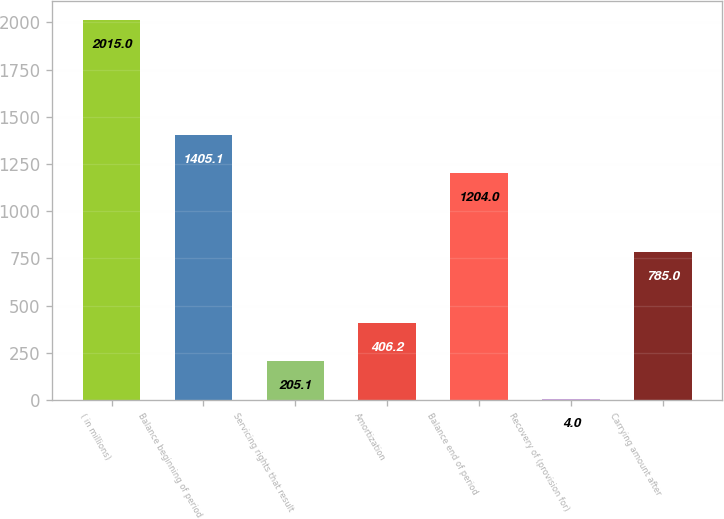Convert chart to OTSL. <chart><loc_0><loc_0><loc_500><loc_500><bar_chart><fcel>( in millions)<fcel>Balance beginning of period<fcel>Servicing rights that result<fcel>Amortization<fcel>Balance end of period<fcel>Recovery of (provision for)<fcel>Carrying amount after<nl><fcel>2015<fcel>1405.1<fcel>205.1<fcel>406.2<fcel>1204<fcel>4<fcel>785<nl></chart> 